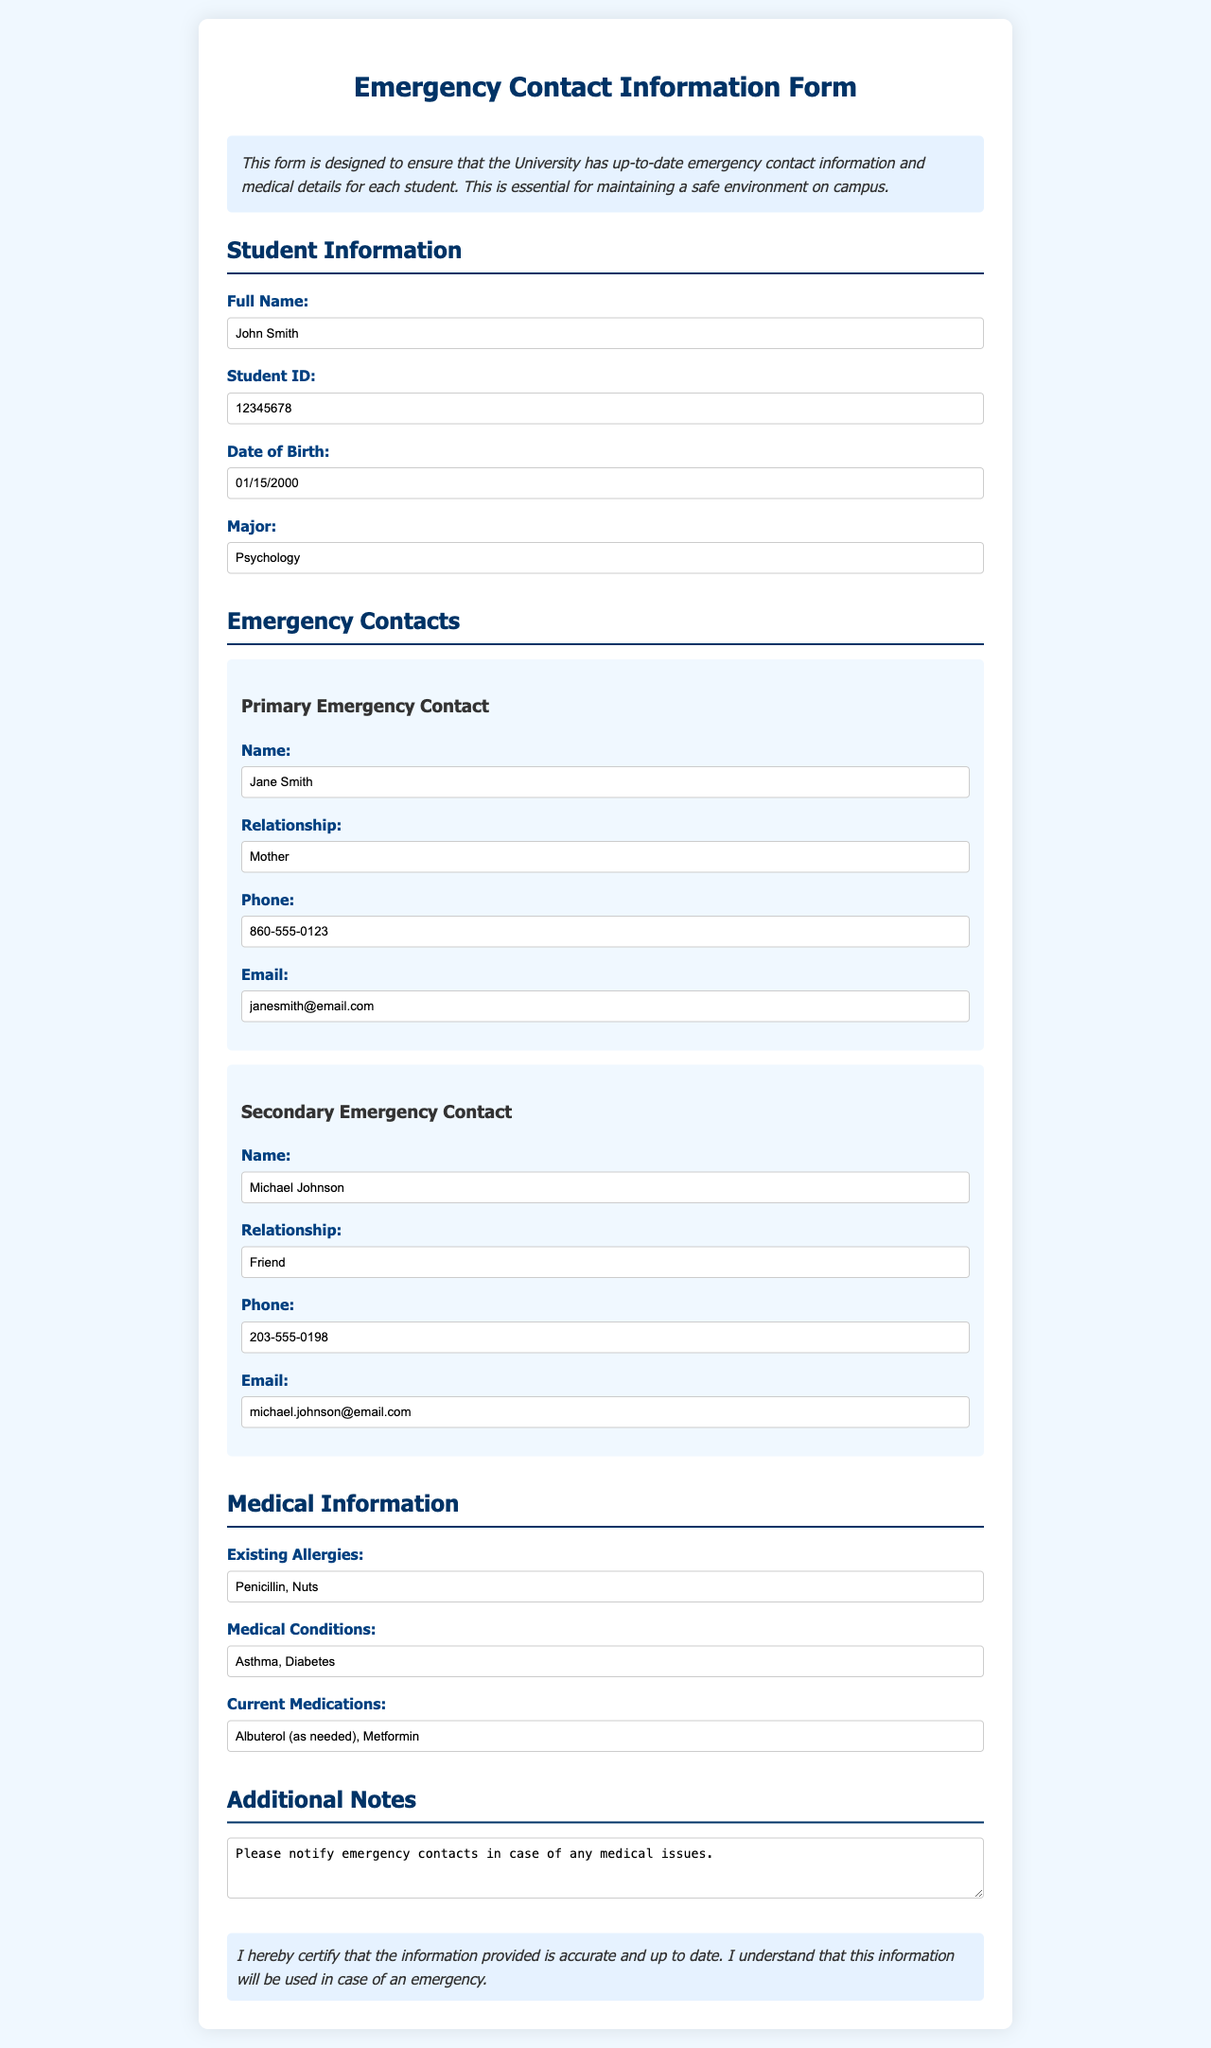What is the full name of the student? The full name is provided in the Student Information section, which lists the name as John Smith.
Answer: John Smith What is the student's date of birth? The date of birth is provided in the Student Information section as 01/15/2000.
Answer: 01/15/2000 Who is the primary emergency contact? The primary emergency contact's name is listed in the Emergency Contacts section as Jane Smith.
Answer: Jane Smith What is the phone number of the secondary emergency contact? The secondary emergency contact's phone number is found in the Emergency Contacts section, which lists it as 203-555-0198.
Answer: 203-555-0198 What allergies does the student have? Existing allergies are listed in the Medical Information section as Penicillin, Nuts.
Answer: Penicillin, Nuts What medical condition is mentioned for the student? The medical conditions are provided in the Medical Information section, which includes Asthma and Diabetes.
Answer: Asthma, Diabetes What relationship does the primary emergency contact have with the student? The relationship of the primary emergency contact is stated in the Emergency Contacts section as Mother.
Answer: Mother What current medication is listed for the student? Current medications are listed in the Medical Information section as Albuterol (as needed), Metformin.
Answer: Albuterol (as needed), Metformin What note is included regarding emergency contacts? The additional notes section contains a request to "Please notify emergency contacts in case of any medical issues."
Answer: Please notify emergency contacts in case of any medical issues 